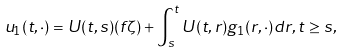<formula> <loc_0><loc_0><loc_500><loc_500>u _ { 1 } ( t , \cdot ) = U ( t , s ) ( f \zeta ) + \int _ { s } ^ { t } U ( t , r ) g _ { 1 } ( r , \cdot ) d r , t \geq s ,</formula> 